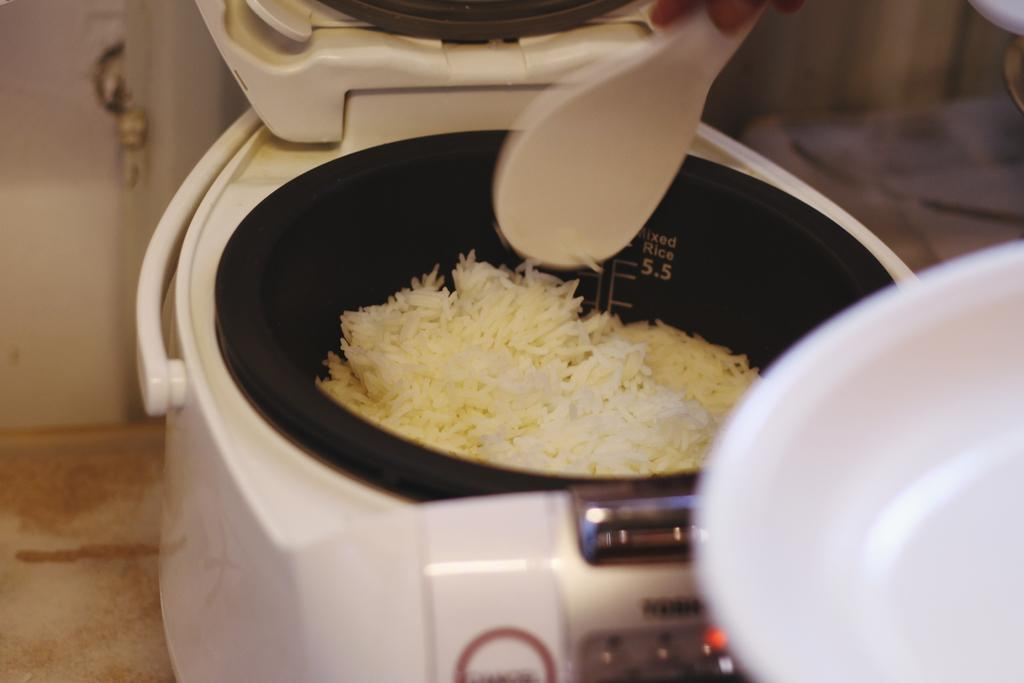<image>
Give a short and clear explanation of the subsequent image. An open rice cooker that indicates it's for mixed rice on the inside is partially full of rice. 